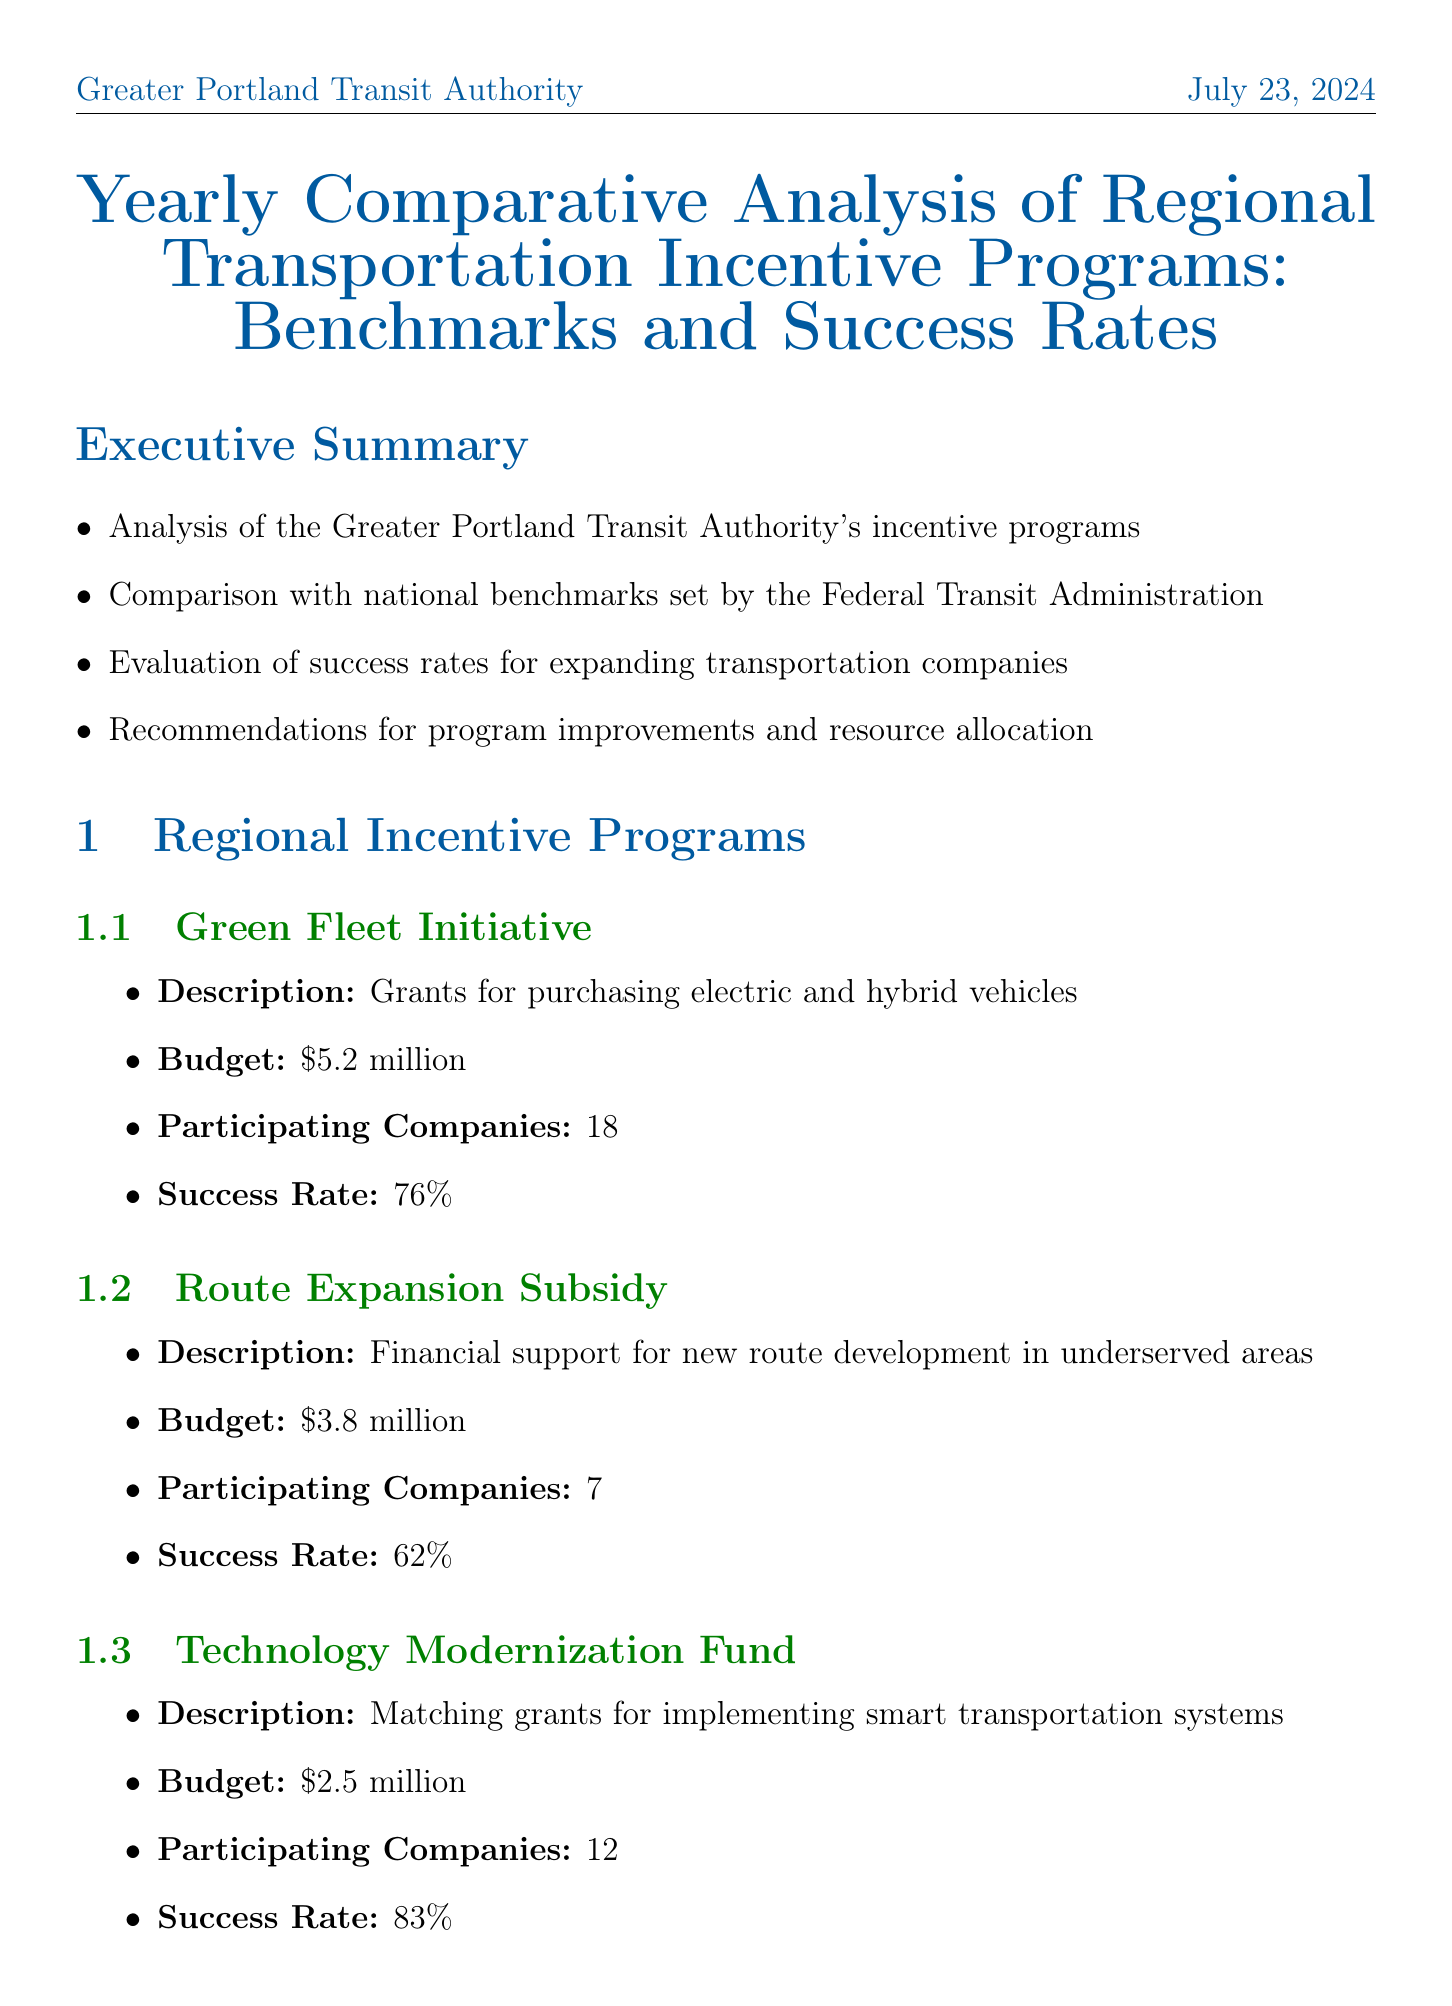What is the budget for the Green Fleet Initiative? The budget for the Green Fleet Initiative is specified in the document.
Answer: $5.2 million How many companies participated in the Technology Modernization Fund? The number of participating companies in the Technology Modernization Fund is provided in the regional incentive programs section.
Answer: 12 What is the success rate for the Route Expansion Subsidy? The success rate for the Route Expansion Subsidy can be found in the report's regional incentive programs.
Answer: 62% What is the average success rate for national benchmarks? The average success rate for national benchmarks is mentioned in the national benchmarks section of the document.
Answer: 68% Which program had the highest success rate? The program with the highest success rate can be identified by comparing the success rates from the regional incentive programs listed.
Answer: Technology Modernization Fund What percentage did Greater Portland Transit Authority exceed the national average in budget performance? This information is summarized in the comparative analysis section regarding budget performance.
Answer: 17% What is one of the challenges noted in the report? Challenges and lessons learned are explicitly mentioned, summarizing various difficulties experienced in the programs.
Answer: Complex application process What is the proposed budget for the MaaS Integration Subsidy? The proposed budget for the MaaS Integration Subsidy can be found in the future focus section of the document.
Answer: $1.8 million 